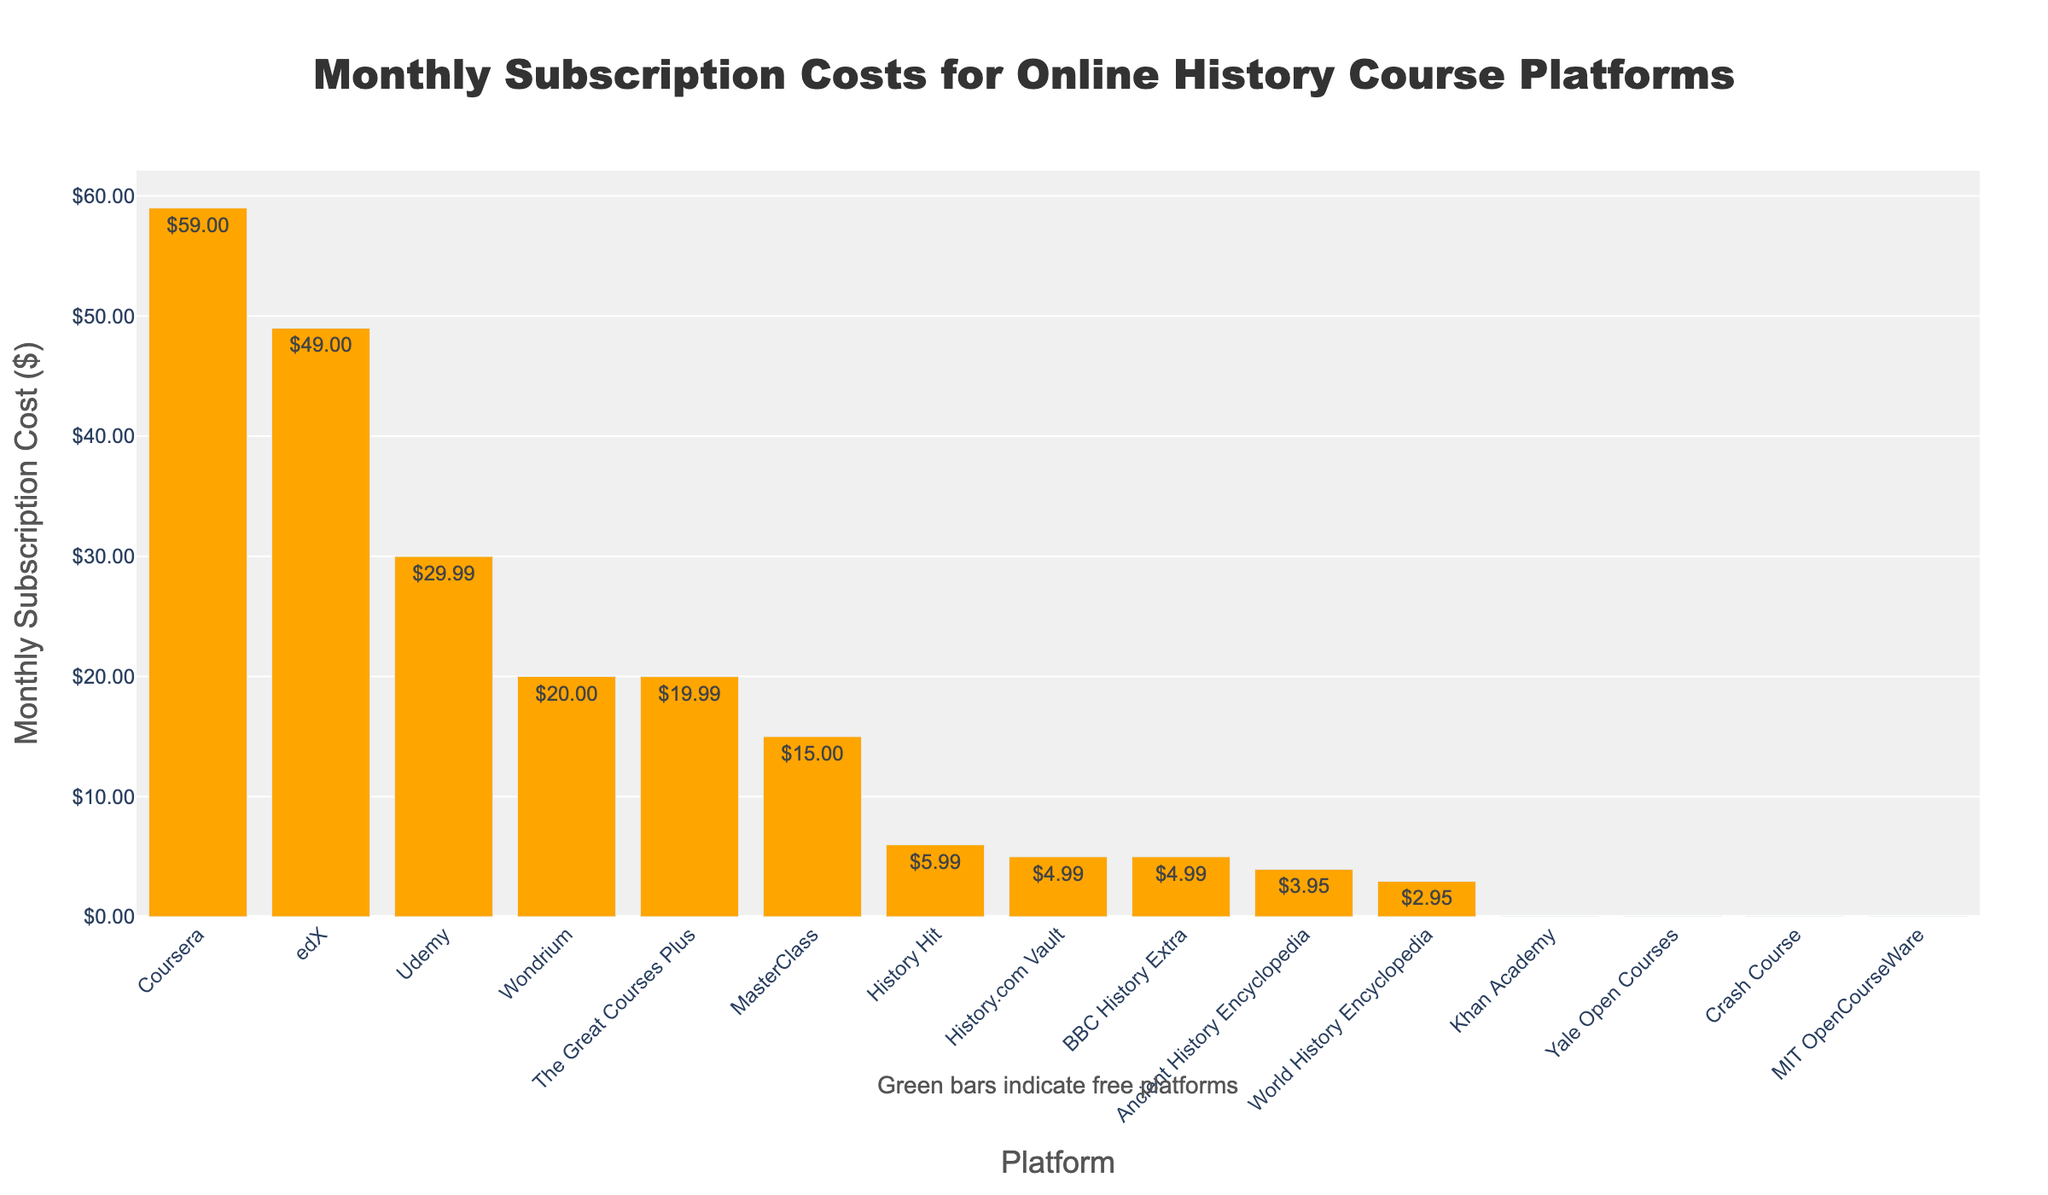Which platform has the highest monthly subscription cost? The platform with the highest bar corresponds to the highest monthly subscription cost.
Answer: Coursera Which platforms are free? The green-colored bars indicate platforms with a $0.00 monthly subscription cost.
Answer: Khan Academy, Yale Open Courses, Crash Course, MIT OpenCourseWare What is the difference in the monthly subscription cost between The Great Courses Plus and History Hit? The bar heights represent the costs. Subtract the monthly cost of History Hit from The Great Courses Plus. ($19.99 - $5.99)
Answer: $14.00 Which platform is more expensive, Udemy or Wondrium, and by how much? The bar heights represent the costs. Subtract the monthly cost of Wondrium from Udemy. ($29.99 - $20.00)
Answer: Udemy, $9.99 What is the total monthly subscription cost of platforms that are not free? Sum the costs of platforms with orange bars. ($19.99 + $15.00 + $59.00 + $49.00 + $29.99 + $5.99 + $20.00 + $4.99 + $4.99 + $3.95 + $2.95)
Answer: $215.84 What is the average monthly subscription cost of all platforms? Sum the costs of all platforms and divide by the number of platforms. (($19.99 + $15.00 + $59.00 + $49.00 + $29.99 + $5.99 + $20.00 + $4.99 + $0.00 + $0.00 + $4.99 + $3.95 + $2.95 + $0.00 + $0.00) / 15)
Answer: $14.39 How many platforms charge less than $10 per month? Count the bars that are shorter and correspond to costs below $10.00.
Answer: 6 What is the monthly subscription cost of BBC History Extra, and is it greater than $3.95? Identify the height of the bar for BBC History Extra and compare the cost with $3.95. (BBC History Extra = $4.99, $3.95 < $4.99)
Answer: $4.99, Yes Among platforms with subscription fees, which has the smallest cost, and what is it? Among the orange bars, identify the smallest one.
Answer: World History Encyclopedia, $2.95 